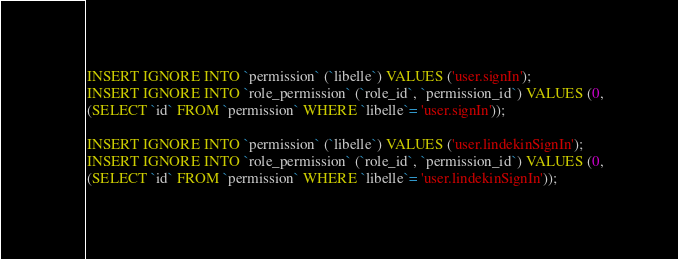Convert code to text. <code><loc_0><loc_0><loc_500><loc_500><_SQL_>INSERT IGNORE INTO `permission` (`libelle`) VALUES ('user.signIn');
INSERT IGNORE INTO `role_permission` (`role_id`, `permission_id`) VALUES (0, 
(SELECT `id` FROM `permission` WHERE `libelle`= 'user.signIn'));

INSERT IGNORE INTO `permission` (`libelle`) VALUES ('user.lindekinSignIn');
INSERT IGNORE INTO `role_permission` (`role_id`, `permission_id`) VALUES (0, 
(SELECT `id` FROM `permission` WHERE `libelle`= 'user.lindekinSignIn'));

</code> 